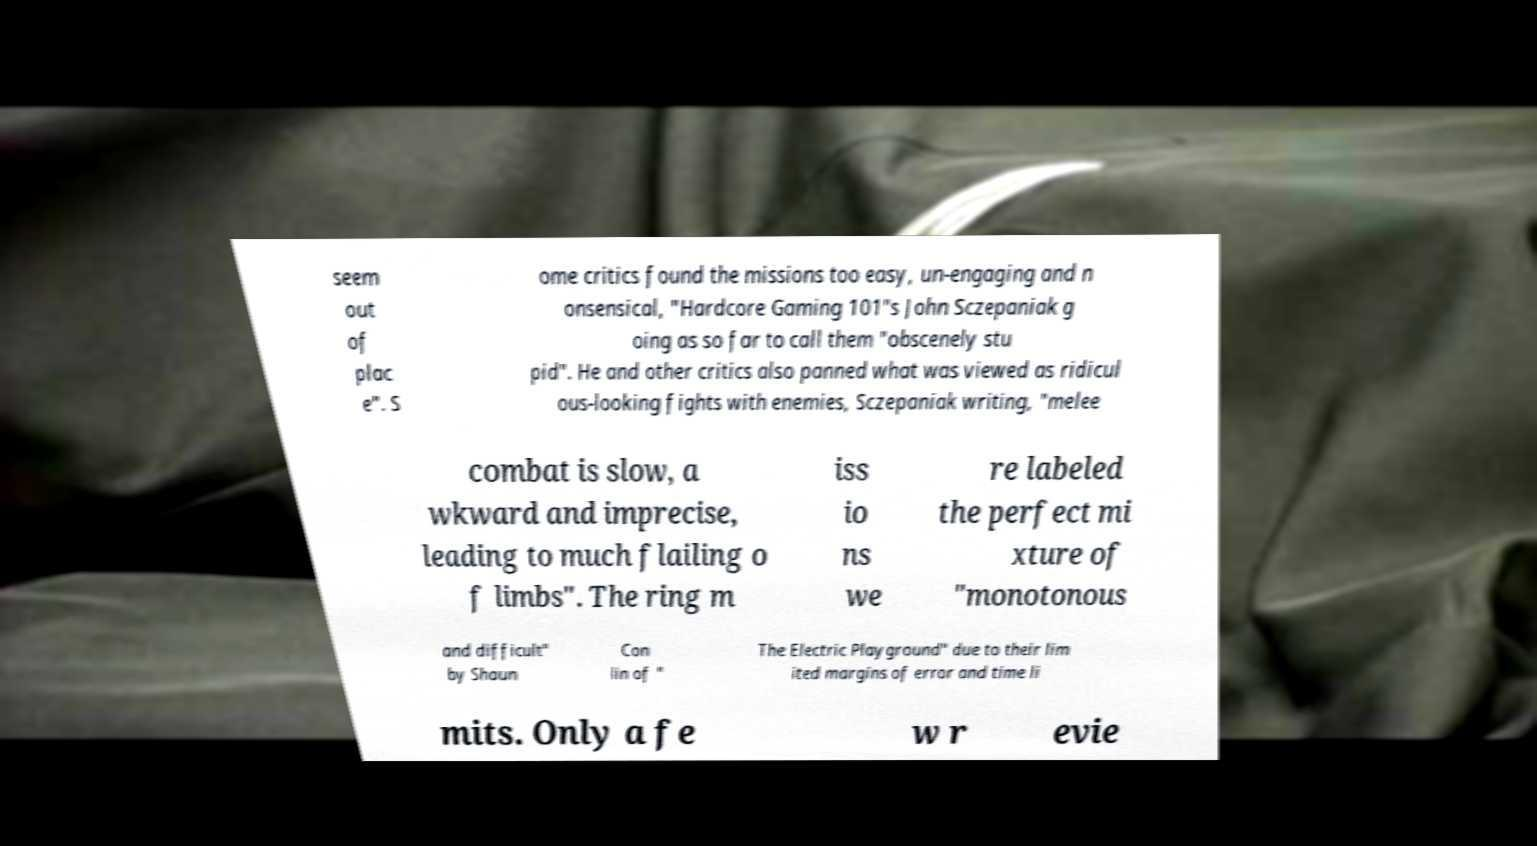What messages or text are displayed in this image? I need them in a readable, typed format. seem out of plac e". S ome critics found the missions too easy, un-engaging and n onsensical, "Hardcore Gaming 101"s John Sczepaniak g oing as so far to call them "obscenely stu pid". He and other critics also panned what was viewed as ridicul ous-looking fights with enemies, Sczepaniak writing, "melee combat is slow, a wkward and imprecise, leading to much flailing o f limbs". The ring m iss io ns we re labeled the perfect mi xture of "monotonous and difficult" by Shaun Con lin of " The Electric Playground" due to their lim ited margins of error and time li mits. Only a fe w r evie 